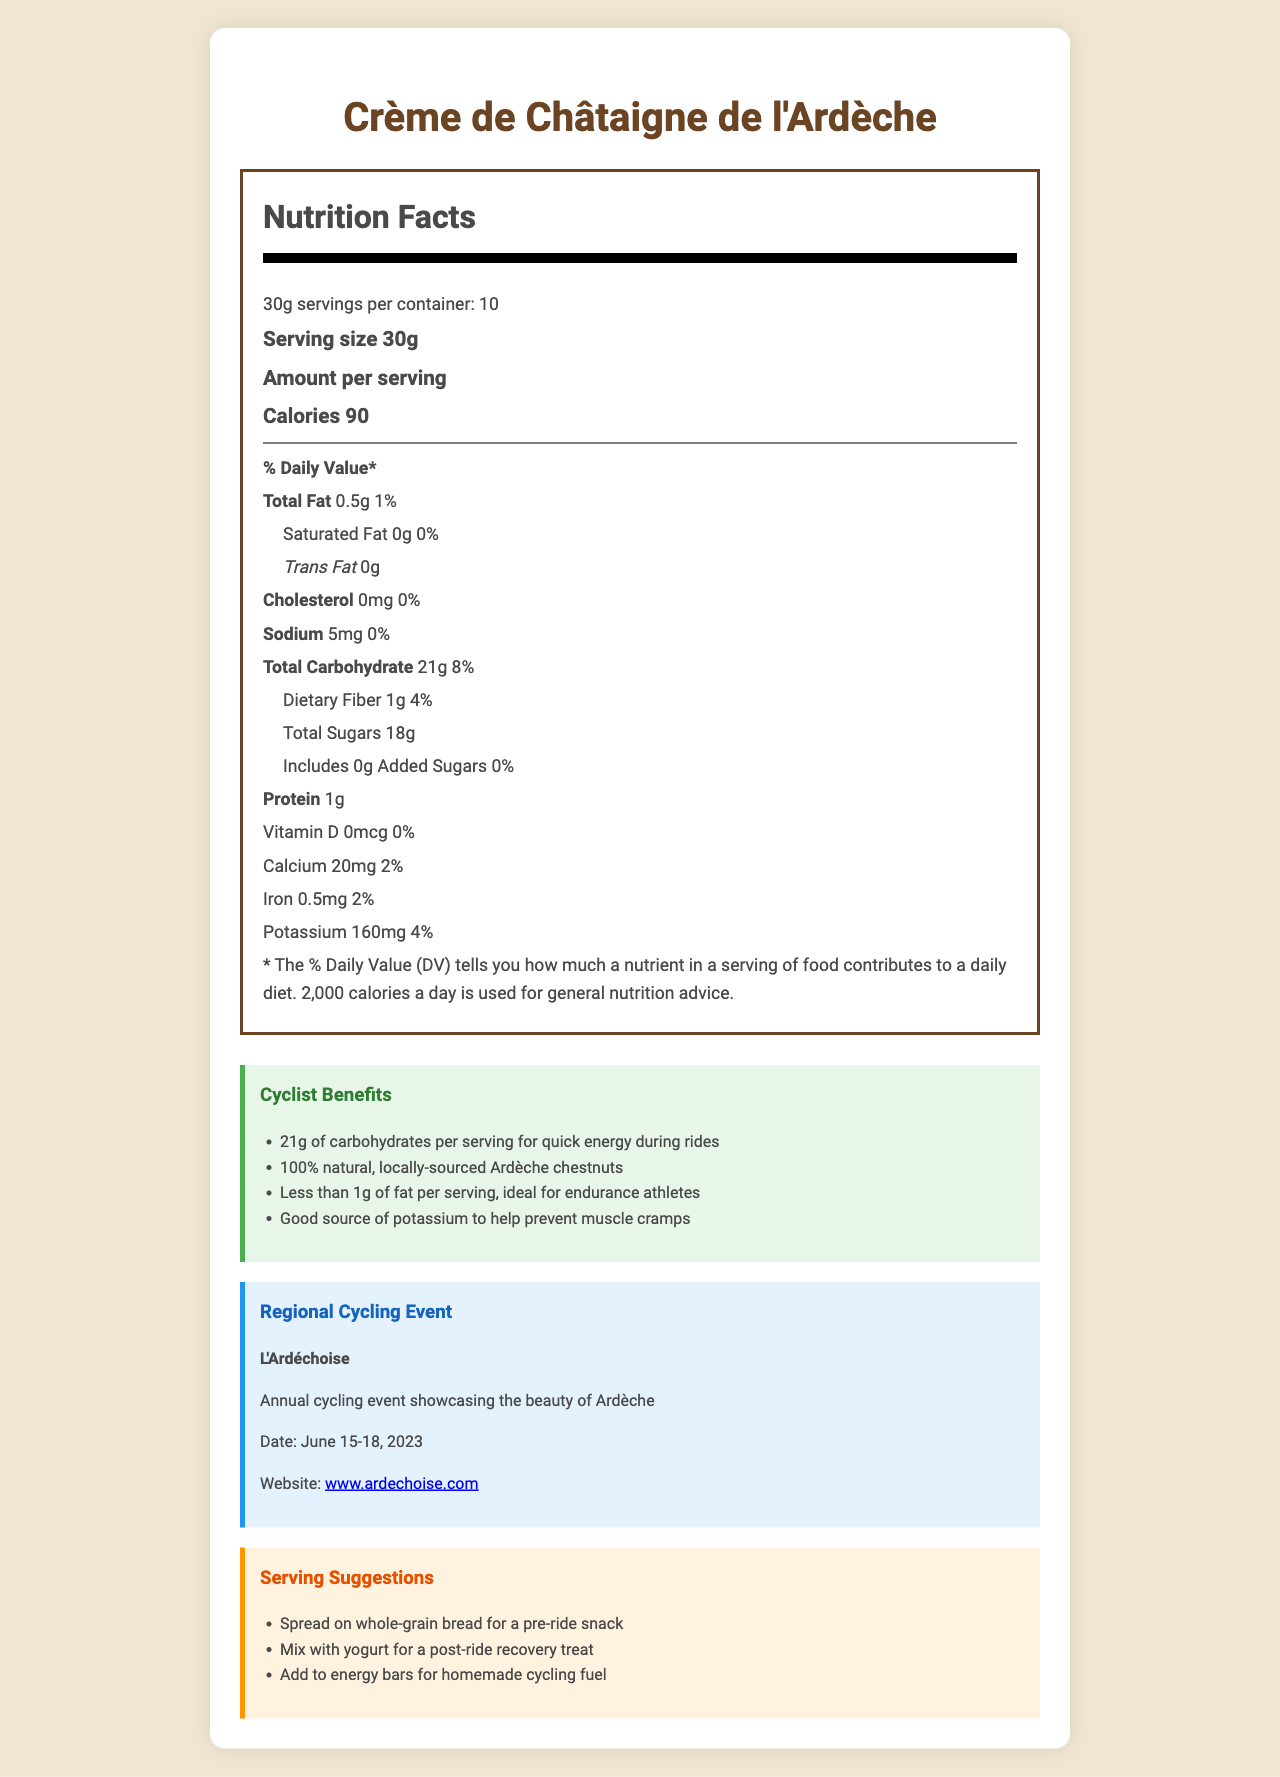What is the serving size of Crème de Châtaigne de l'Ardèche? The document states that the serving size is 30g.
Answer: 30g How many calories are in one serving of the chestnut spread? According to the Nutrition Facts, there are 90 calories per serving.
Answer: 90 calories What is the total carbohydrate content per serving? The Nutrition Facts section specifies that total carbohydrate content per serving is 21g.
Answer: 21g What percentage of the daily value does the dietary fiber content represent? The document indicates that the dietary fiber content is 4% of the daily value.
Answer: 4% What are the main ingredients of this chestnut spread? The ingredients listed are Ardèche chestnuts, water, and natural vanilla extract.
Answer: Ardèche chestnuts, water, natural vanilla extract Does this product contain any added sugars? The Nutrition Facts section shows that the product contains 0g of added sugars.
Answer: No What is the sodium content in a serving of this chestnut spread? The Nutrition Facts specify that the sodium content per serving is 5mg.
Answer: 5mg How long should the chestnut spread be consumed after opening? The storage instructions advise to consume the product within 2 weeks after opening.
Answer: Within 2 weeks Which of the following is not a benefit mentioned for cyclists using this chestnut spread? A. Quick energy B. High protein content C. Low fat D. Potassium source The document highlights quick energy, low fat, and potassium source as benefits, but not high protein content.
Answer: B Which certifications does the Crème de Châtaigne de l'Ardèche hold? A. AOC B. Label Rouge C. AOC and Label Rouge D. Bio The product holds both AOC and Label Rouge certifications.
Answer: C Is the packaging of the product sustainable? The document states that the packaging is made from 100% recycled materials.
Answer: Yes Does the product contain any allergens? It is produced in a facility that processes tree nuts, as stated in the allergen information section.
Answer: Yes Summarize the main benefits of the Crème de Châtaigne de l'Ardèche for cyclists. The benefits are highlighted in the cyclist benefits section, focusing on energy boost, natural ingredients, low fat content, and potassium source.
Answer: The chestnut spread offers quick energy from 21g of carbohydrates per serving and includes 100% natural ingredients like locally-sourced Ardèche chestnuts. It is low in fat with less than 1g of fat per serving and is a good source of potassium, which helps prevent muscle cramps. What is the date of the regional cycling event, L'Ardéchoise? The document states that L'Ardéchoise is scheduled for June 15-18, 2023.
Answer: June 15-18, 2023 What are some suggested ways to consume the chestnut spread? The serving suggestions section lists these methods of consumption.
Answer: Spread on whole-grain bread for a pre-ride snack, mix with yogurt for a post-ride recovery treat, add to energy bars for homemade cycling fuel How many proteins are in one serving of the chestnut spread? The Nutrition Facts state that there is 1g of protein per serving.
Answer: 1g Does the document mention the amount of vitamin C in the chestnut spread? The document does not provide any information about the amount of vitamin C.
Answer: No 